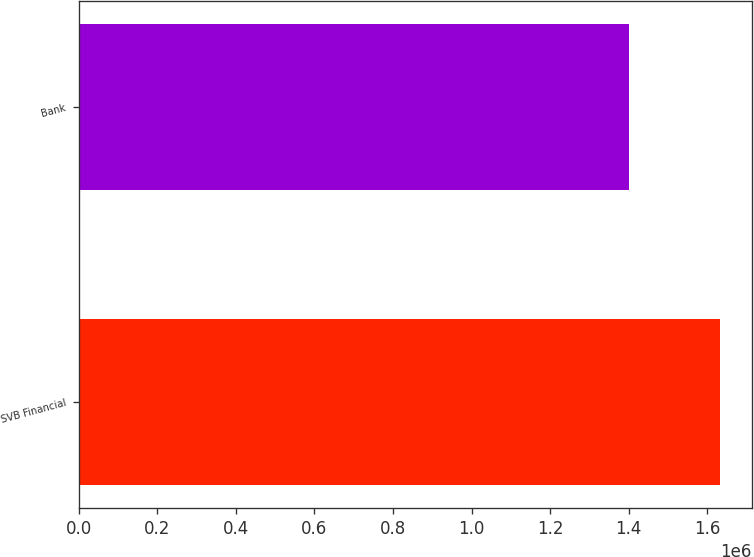Convert chart. <chart><loc_0><loc_0><loc_500><loc_500><bar_chart><fcel>SVB Financial<fcel>Bank<nl><fcel>1.63247e+06<fcel>1.40026e+06<nl></chart> 